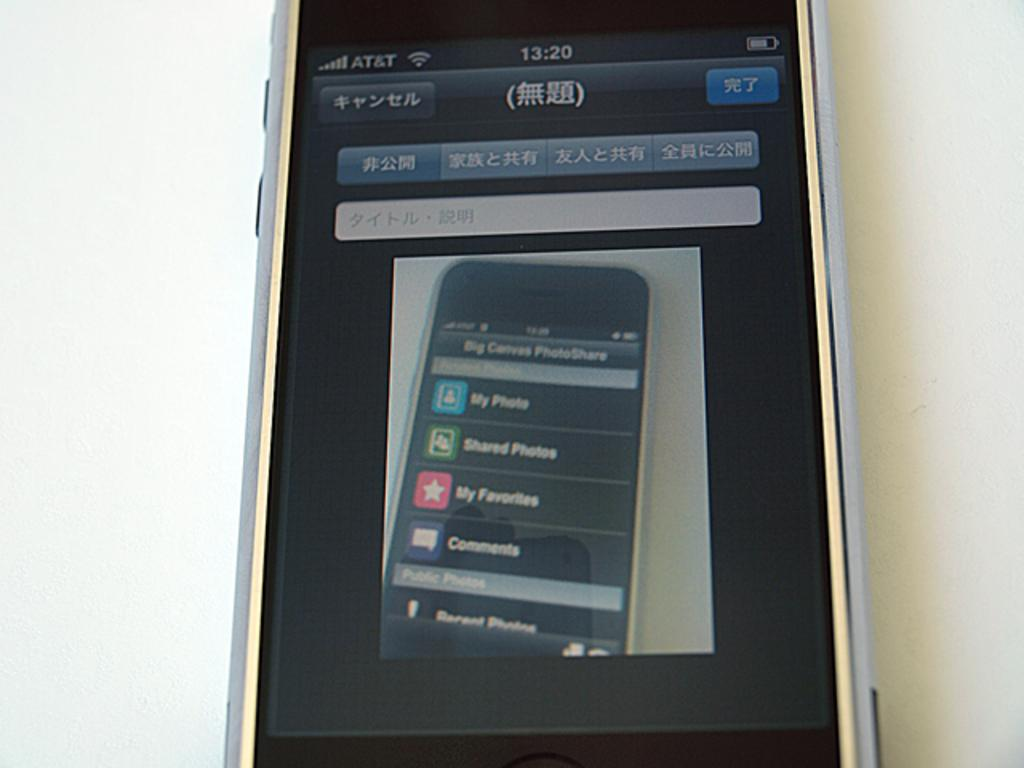<image>
Create a compact narrative representing the image presented. An At&T eletronic device showing a photo of another AT&T device on the screen. 